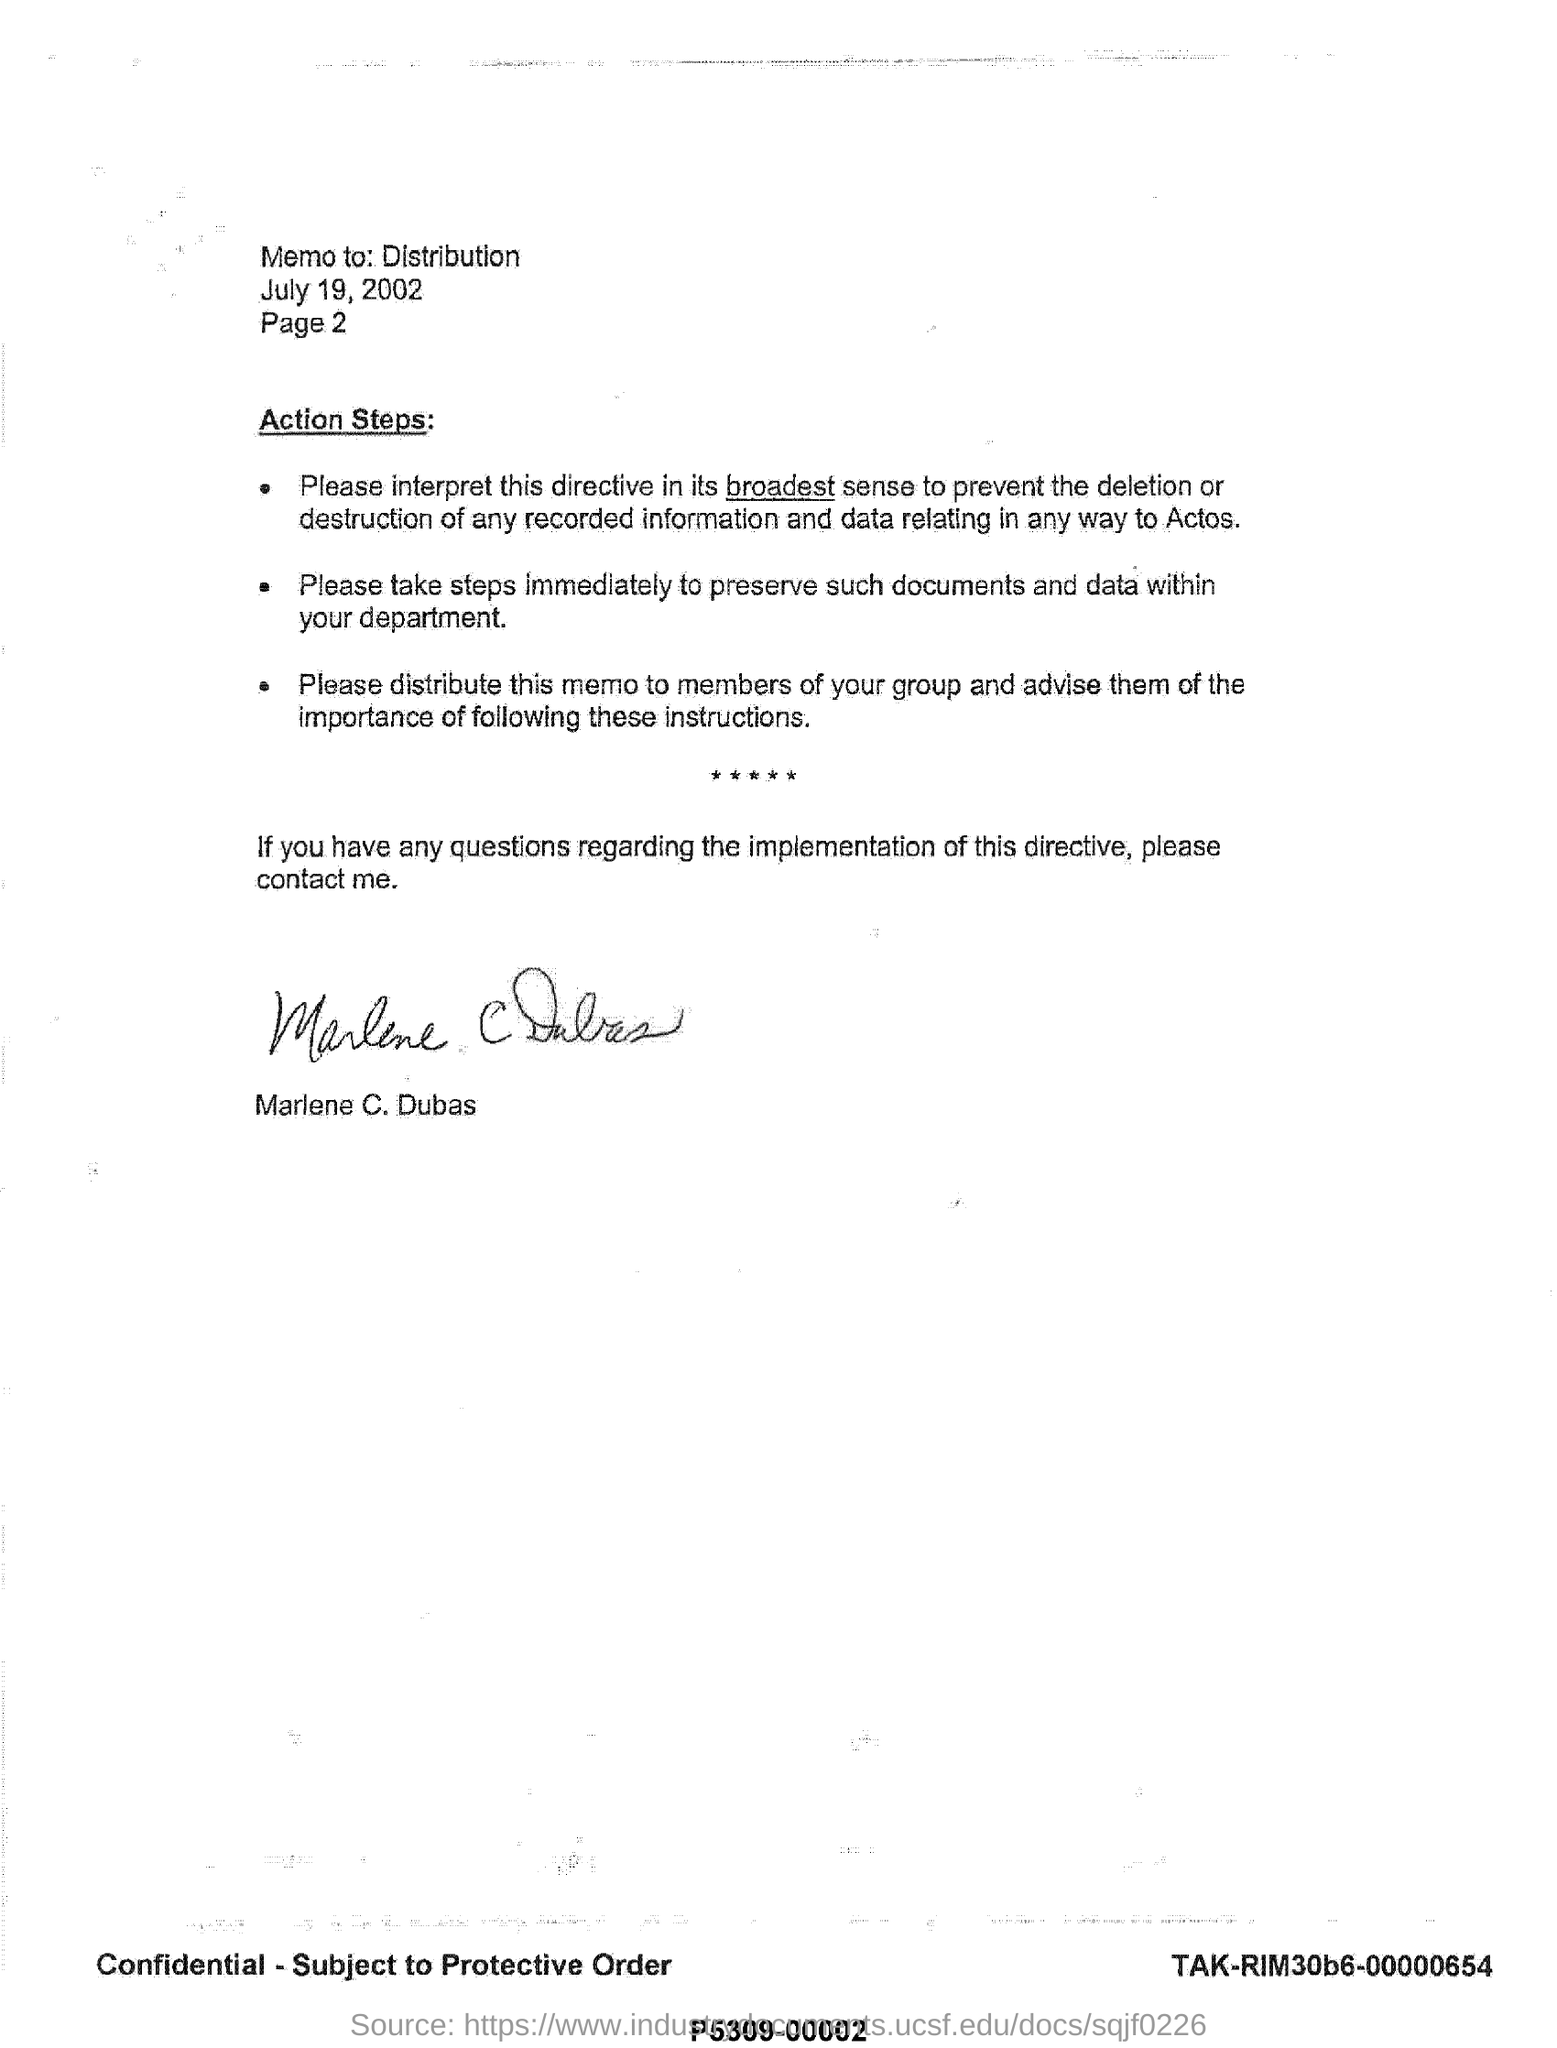Who is this Memo to?
Ensure brevity in your answer.  Distribution. What is the date mentioned?
Keep it short and to the point. July 19, 2002. Whose signature is present at the bottom?
Your response must be concise. MARLENE C. DUBAS. 